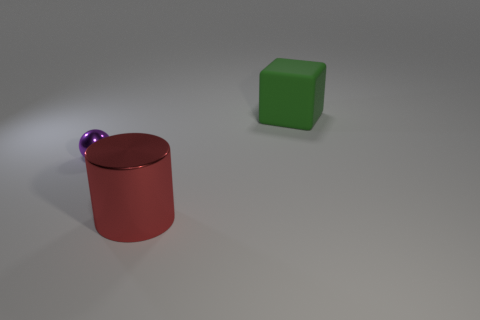What number of other objects are the same material as the big red cylinder?
Provide a short and direct response. 1. Does the metallic object behind the big metallic cylinder have the same color as the large object left of the green cube?
Your answer should be compact. No. What shape is the metallic thing behind the metal object that is in front of the tiny shiny thing?
Keep it short and to the point. Sphere. How many other things are there of the same color as the tiny shiny object?
Offer a very short reply. 0. Is the large thing that is in front of the tiny purple thing made of the same material as the object that is to the right of the big shiny thing?
Provide a succinct answer. No. What size is the object on the right side of the big red metal cylinder?
Provide a short and direct response. Large. Is there any other thing that is the same size as the purple thing?
Offer a terse response. No. There is a big thing behind the purple shiny sphere; what is its shape?
Provide a short and direct response. Cube. What number of other rubber things have the same shape as the large matte object?
Ensure brevity in your answer.  0. Is the number of large green rubber things in front of the big green cube the same as the number of large red shiny objects behind the big red shiny cylinder?
Your answer should be very brief. Yes. 